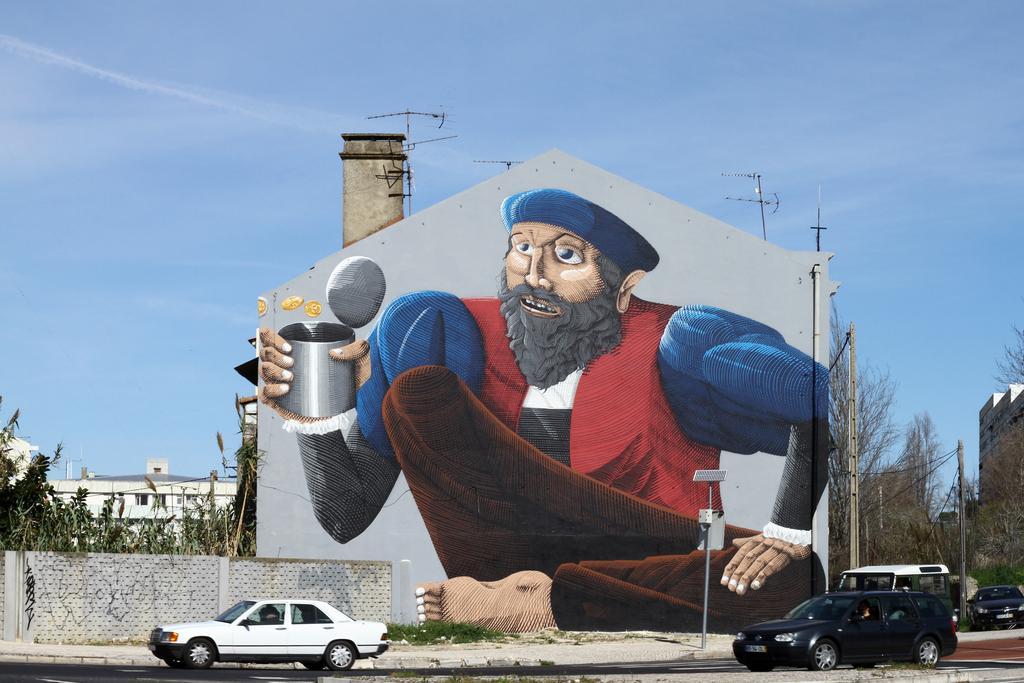Please provide a concise description of this image. In this image we can see few vehicles on the road and there is a building and we can see the painting of a person holding an object on the building wall. There are few buildings in the background and we can see some trees and we can see the sky. 